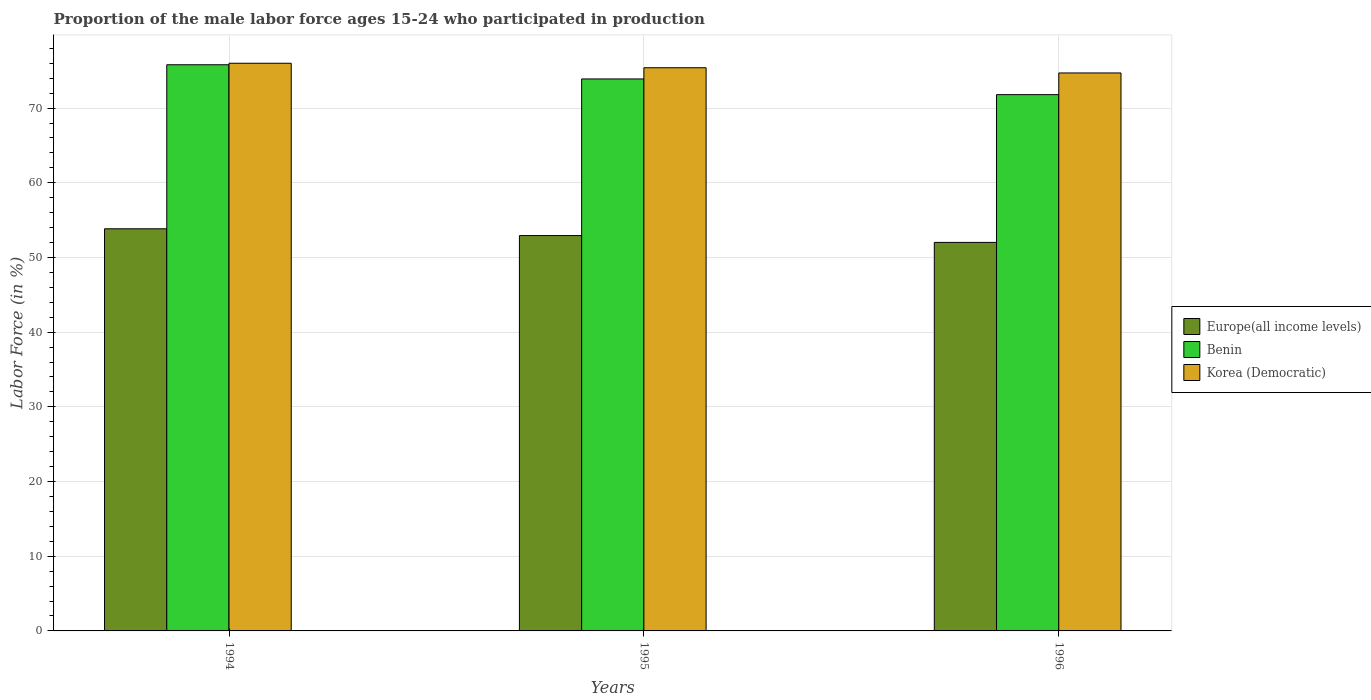How many different coloured bars are there?
Your response must be concise. 3. How many groups of bars are there?
Give a very brief answer. 3. How many bars are there on the 1st tick from the left?
Offer a terse response. 3. What is the proportion of the male labor force who participated in production in Europe(all income levels) in 1995?
Your response must be concise. 52.93. Across all years, what is the maximum proportion of the male labor force who participated in production in Benin?
Give a very brief answer. 75.8. Across all years, what is the minimum proportion of the male labor force who participated in production in Europe(all income levels)?
Provide a succinct answer. 52.02. In which year was the proportion of the male labor force who participated in production in Benin maximum?
Ensure brevity in your answer.  1994. In which year was the proportion of the male labor force who participated in production in Korea (Democratic) minimum?
Give a very brief answer. 1996. What is the total proportion of the male labor force who participated in production in Europe(all income levels) in the graph?
Give a very brief answer. 158.79. What is the difference between the proportion of the male labor force who participated in production in Europe(all income levels) in 1995 and that in 1996?
Make the answer very short. 0.91. What is the difference between the proportion of the male labor force who participated in production in Korea (Democratic) in 1996 and the proportion of the male labor force who participated in production in Europe(all income levels) in 1995?
Your answer should be compact. 21.77. What is the average proportion of the male labor force who participated in production in Benin per year?
Your answer should be very brief. 73.83. In the year 1996, what is the difference between the proportion of the male labor force who participated in production in Korea (Democratic) and proportion of the male labor force who participated in production in Europe(all income levels)?
Offer a terse response. 22.68. What is the ratio of the proportion of the male labor force who participated in production in Benin in 1994 to that in 1995?
Give a very brief answer. 1.03. Is the proportion of the male labor force who participated in production in Europe(all income levels) in 1994 less than that in 1996?
Your answer should be compact. No. What is the difference between the highest and the second highest proportion of the male labor force who participated in production in Korea (Democratic)?
Your response must be concise. 0.6. What is the difference between the highest and the lowest proportion of the male labor force who participated in production in Europe(all income levels)?
Provide a succinct answer. 1.82. In how many years, is the proportion of the male labor force who participated in production in Benin greater than the average proportion of the male labor force who participated in production in Benin taken over all years?
Your response must be concise. 2. Is the sum of the proportion of the male labor force who participated in production in Korea (Democratic) in 1994 and 1995 greater than the maximum proportion of the male labor force who participated in production in Benin across all years?
Keep it short and to the point. Yes. What does the 2nd bar from the left in 1996 represents?
Provide a succinct answer. Benin. What does the 1st bar from the right in 1996 represents?
Your response must be concise. Korea (Democratic). How many years are there in the graph?
Make the answer very short. 3. Are the values on the major ticks of Y-axis written in scientific E-notation?
Offer a very short reply. No. Does the graph contain any zero values?
Offer a very short reply. No. Where does the legend appear in the graph?
Your answer should be compact. Center right. What is the title of the graph?
Offer a terse response. Proportion of the male labor force ages 15-24 who participated in production. Does "Mexico" appear as one of the legend labels in the graph?
Your response must be concise. No. What is the label or title of the X-axis?
Give a very brief answer. Years. What is the label or title of the Y-axis?
Offer a very short reply. Labor Force (in %). What is the Labor Force (in %) of Europe(all income levels) in 1994?
Make the answer very short. 53.84. What is the Labor Force (in %) of Benin in 1994?
Ensure brevity in your answer.  75.8. What is the Labor Force (in %) in Europe(all income levels) in 1995?
Your answer should be very brief. 52.93. What is the Labor Force (in %) of Benin in 1995?
Offer a terse response. 73.9. What is the Labor Force (in %) in Korea (Democratic) in 1995?
Keep it short and to the point. 75.4. What is the Labor Force (in %) in Europe(all income levels) in 1996?
Ensure brevity in your answer.  52.02. What is the Labor Force (in %) of Benin in 1996?
Provide a short and direct response. 71.8. What is the Labor Force (in %) in Korea (Democratic) in 1996?
Ensure brevity in your answer.  74.7. Across all years, what is the maximum Labor Force (in %) of Europe(all income levels)?
Offer a very short reply. 53.84. Across all years, what is the maximum Labor Force (in %) of Benin?
Provide a succinct answer. 75.8. Across all years, what is the minimum Labor Force (in %) of Europe(all income levels)?
Make the answer very short. 52.02. Across all years, what is the minimum Labor Force (in %) in Benin?
Provide a short and direct response. 71.8. Across all years, what is the minimum Labor Force (in %) of Korea (Democratic)?
Your answer should be compact. 74.7. What is the total Labor Force (in %) of Europe(all income levels) in the graph?
Give a very brief answer. 158.79. What is the total Labor Force (in %) of Benin in the graph?
Give a very brief answer. 221.5. What is the total Labor Force (in %) in Korea (Democratic) in the graph?
Provide a succinct answer. 226.1. What is the difference between the Labor Force (in %) in Europe(all income levels) in 1994 and that in 1995?
Ensure brevity in your answer.  0.91. What is the difference between the Labor Force (in %) of Korea (Democratic) in 1994 and that in 1995?
Ensure brevity in your answer.  0.6. What is the difference between the Labor Force (in %) in Europe(all income levels) in 1994 and that in 1996?
Your response must be concise. 1.82. What is the difference between the Labor Force (in %) of Korea (Democratic) in 1994 and that in 1996?
Your answer should be very brief. 1.3. What is the difference between the Labor Force (in %) of Europe(all income levels) in 1995 and that in 1996?
Keep it short and to the point. 0.91. What is the difference between the Labor Force (in %) in Benin in 1995 and that in 1996?
Make the answer very short. 2.1. What is the difference between the Labor Force (in %) in Europe(all income levels) in 1994 and the Labor Force (in %) in Benin in 1995?
Provide a succinct answer. -20.06. What is the difference between the Labor Force (in %) in Europe(all income levels) in 1994 and the Labor Force (in %) in Korea (Democratic) in 1995?
Your answer should be very brief. -21.56. What is the difference between the Labor Force (in %) of Europe(all income levels) in 1994 and the Labor Force (in %) of Benin in 1996?
Ensure brevity in your answer.  -17.96. What is the difference between the Labor Force (in %) in Europe(all income levels) in 1994 and the Labor Force (in %) in Korea (Democratic) in 1996?
Give a very brief answer. -20.86. What is the difference between the Labor Force (in %) in Benin in 1994 and the Labor Force (in %) in Korea (Democratic) in 1996?
Offer a very short reply. 1.1. What is the difference between the Labor Force (in %) in Europe(all income levels) in 1995 and the Labor Force (in %) in Benin in 1996?
Keep it short and to the point. -18.87. What is the difference between the Labor Force (in %) of Europe(all income levels) in 1995 and the Labor Force (in %) of Korea (Democratic) in 1996?
Your answer should be compact. -21.77. What is the difference between the Labor Force (in %) of Benin in 1995 and the Labor Force (in %) of Korea (Democratic) in 1996?
Offer a very short reply. -0.8. What is the average Labor Force (in %) of Europe(all income levels) per year?
Provide a succinct answer. 52.93. What is the average Labor Force (in %) in Benin per year?
Provide a succinct answer. 73.83. What is the average Labor Force (in %) of Korea (Democratic) per year?
Make the answer very short. 75.37. In the year 1994, what is the difference between the Labor Force (in %) of Europe(all income levels) and Labor Force (in %) of Benin?
Provide a short and direct response. -21.96. In the year 1994, what is the difference between the Labor Force (in %) of Europe(all income levels) and Labor Force (in %) of Korea (Democratic)?
Keep it short and to the point. -22.16. In the year 1995, what is the difference between the Labor Force (in %) in Europe(all income levels) and Labor Force (in %) in Benin?
Your response must be concise. -20.97. In the year 1995, what is the difference between the Labor Force (in %) in Europe(all income levels) and Labor Force (in %) in Korea (Democratic)?
Make the answer very short. -22.47. In the year 1995, what is the difference between the Labor Force (in %) in Benin and Labor Force (in %) in Korea (Democratic)?
Make the answer very short. -1.5. In the year 1996, what is the difference between the Labor Force (in %) in Europe(all income levels) and Labor Force (in %) in Benin?
Provide a short and direct response. -19.78. In the year 1996, what is the difference between the Labor Force (in %) of Europe(all income levels) and Labor Force (in %) of Korea (Democratic)?
Your answer should be very brief. -22.68. What is the ratio of the Labor Force (in %) in Europe(all income levels) in 1994 to that in 1995?
Your response must be concise. 1.02. What is the ratio of the Labor Force (in %) in Benin in 1994 to that in 1995?
Your answer should be very brief. 1.03. What is the ratio of the Labor Force (in %) of Korea (Democratic) in 1994 to that in 1995?
Provide a short and direct response. 1.01. What is the ratio of the Labor Force (in %) in Europe(all income levels) in 1994 to that in 1996?
Keep it short and to the point. 1.03. What is the ratio of the Labor Force (in %) in Benin in 1994 to that in 1996?
Ensure brevity in your answer.  1.06. What is the ratio of the Labor Force (in %) in Korea (Democratic) in 1994 to that in 1996?
Provide a succinct answer. 1.02. What is the ratio of the Labor Force (in %) of Europe(all income levels) in 1995 to that in 1996?
Your answer should be very brief. 1.02. What is the ratio of the Labor Force (in %) of Benin in 1995 to that in 1996?
Keep it short and to the point. 1.03. What is the ratio of the Labor Force (in %) of Korea (Democratic) in 1995 to that in 1996?
Keep it short and to the point. 1.01. What is the difference between the highest and the second highest Labor Force (in %) in Europe(all income levels)?
Offer a very short reply. 0.91. What is the difference between the highest and the second highest Labor Force (in %) in Benin?
Offer a terse response. 1.9. What is the difference between the highest and the lowest Labor Force (in %) of Europe(all income levels)?
Your response must be concise. 1.82. 